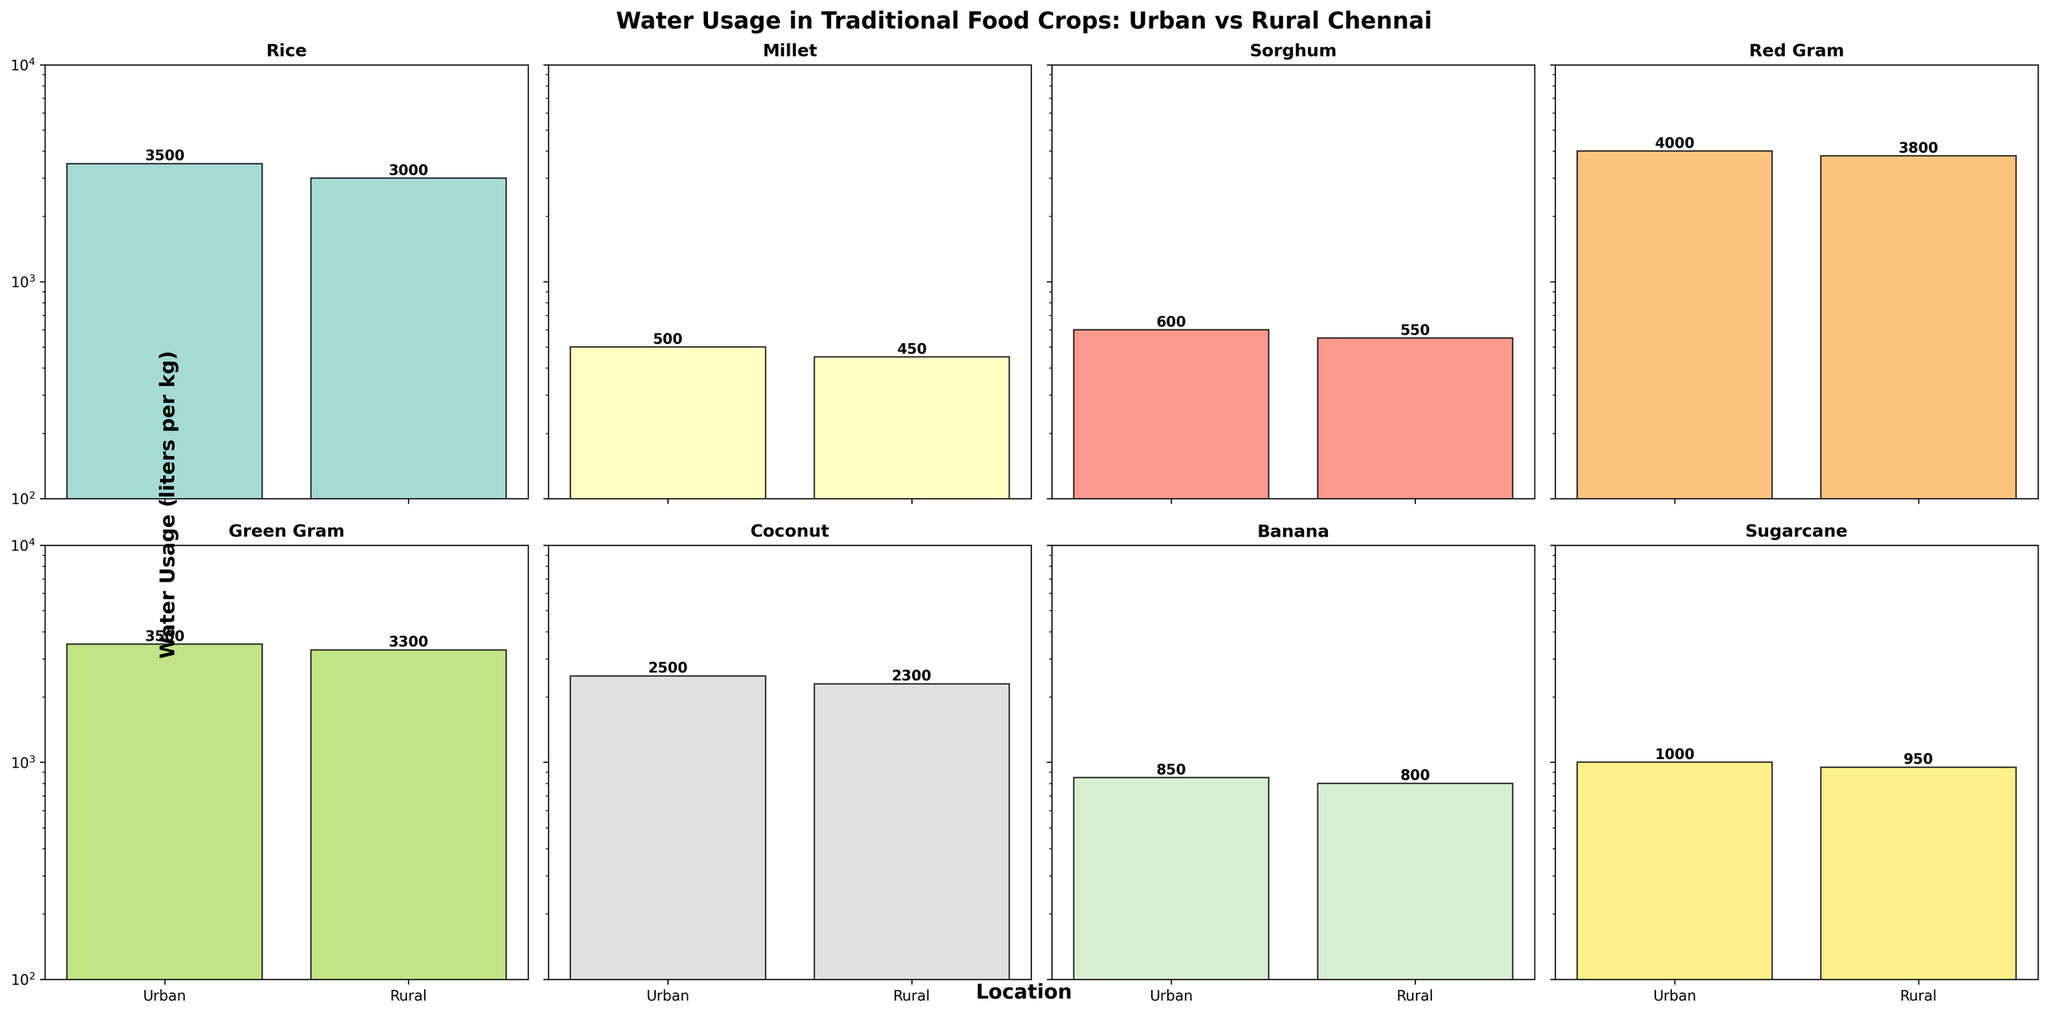How many crops are represented in the figure? There are subplots for each crop. Count the number of unique subplot titles.
Answer: 8 What is the title of the figure? The title is displayed at the top of the entire figure.
Answer: Water Usage in Traditional Food Crops: Urban vs Rural Chennai Which crop shows lower water usage in rural areas than urban areas? Compare the bars in the subplots for each crop to see which has a lower value for rural compared to urban.
Answer: All crops What is the water usage difference between rural and urban areas for Red Gram? Look at the height of the bars for Red Gram and subtract the rural value from the urban value: 4000 liters for urban and 3800 liters for rural.
Answer: 200 liters Which crop has the highest water usage in urban areas? Identify the tallest bar in the urban sections of the subplots.
Answer: Red Gram Which crop requires the least water in rural areas? Identify the shortest bar in the rural sections of the subplots.
Answer: Banana Does Sugarcane show a higher water usage in urban or rural areas? Compare the heights of the Sugarcane bars in both urban and rural subplots.
Answer: Urban What is the range of water usage in Chennai for Green Gram across urban and rural areas? Identify the minimum and maximum values for Green Gram from urban and rural subplots: 3500 liters for urban and 3300 liters for rural, then compute the range.
Answer: 200 liters Which crop appears to have the smallest relative difference in water usage between urban and rural areas? Calculate the relative differences for each crop and find the smallest one: For example, (500-450)/500 = 0.1 or 10% for Millet, compare it with other crops.
Answer: Millet 